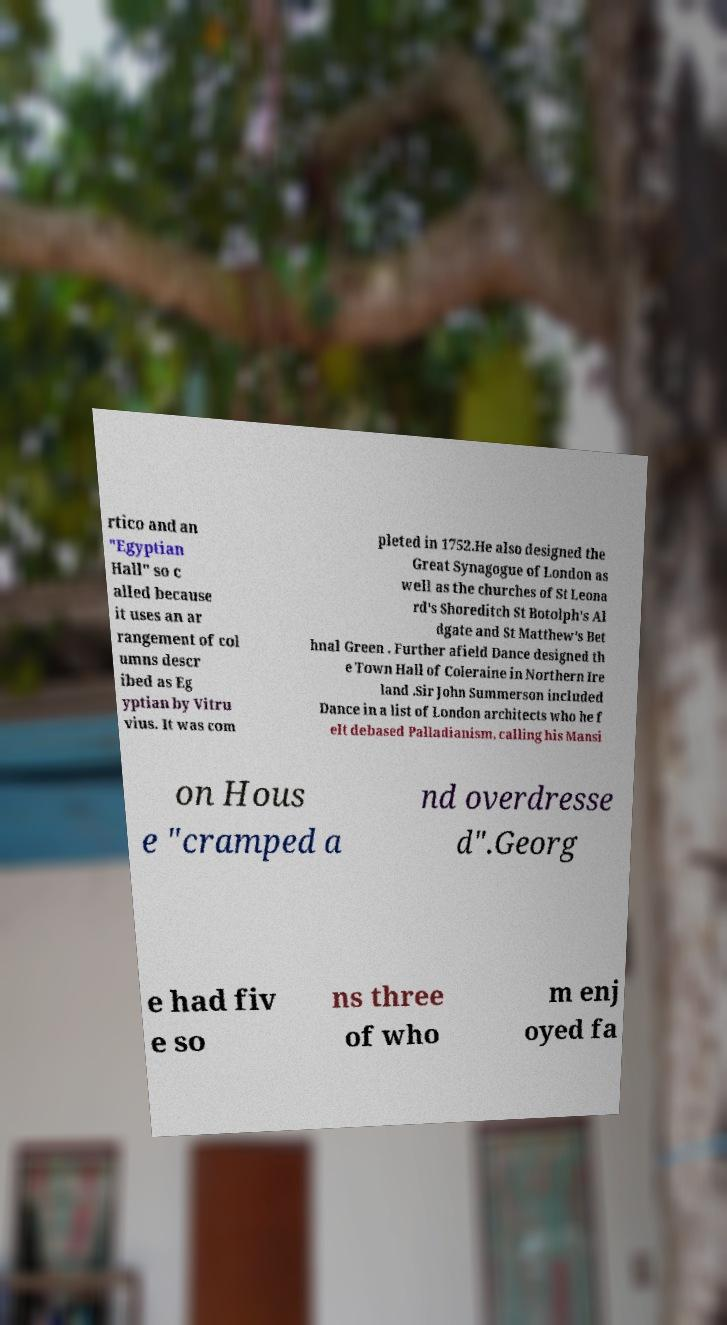I need the written content from this picture converted into text. Can you do that? rtico and an "Egyptian Hall" so c alled because it uses an ar rangement of col umns descr ibed as Eg yptian by Vitru vius. It was com pleted in 1752.He also designed the Great Synagogue of London as well as the churches of St Leona rd's Shoreditch St Botolph's Al dgate and St Matthew's Bet hnal Green . Further afield Dance designed th e Town Hall of Coleraine in Northern Ire land .Sir John Summerson included Dance in a list of London architects who he f elt debased Palladianism, calling his Mansi on Hous e "cramped a nd overdresse d".Georg e had fiv e so ns three of who m enj oyed fa 